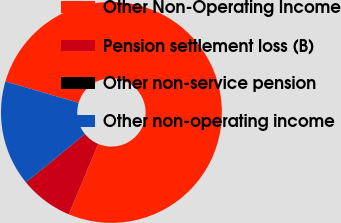<chart> <loc_0><loc_0><loc_500><loc_500><pie_chart><fcel>Other Non-Operating Income<fcel>Pension settlement loss (B)<fcel>Other non-service pension<fcel>Other non-operating income<nl><fcel>76.77%<fcel>7.74%<fcel>0.07%<fcel>15.41%<nl></chart> 